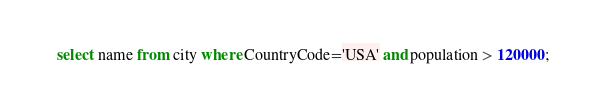Convert code to text. <code><loc_0><loc_0><loc_500><loc_500><_SQL_>select name from city where CountryCode='USA' and population > 120000;
</code> 